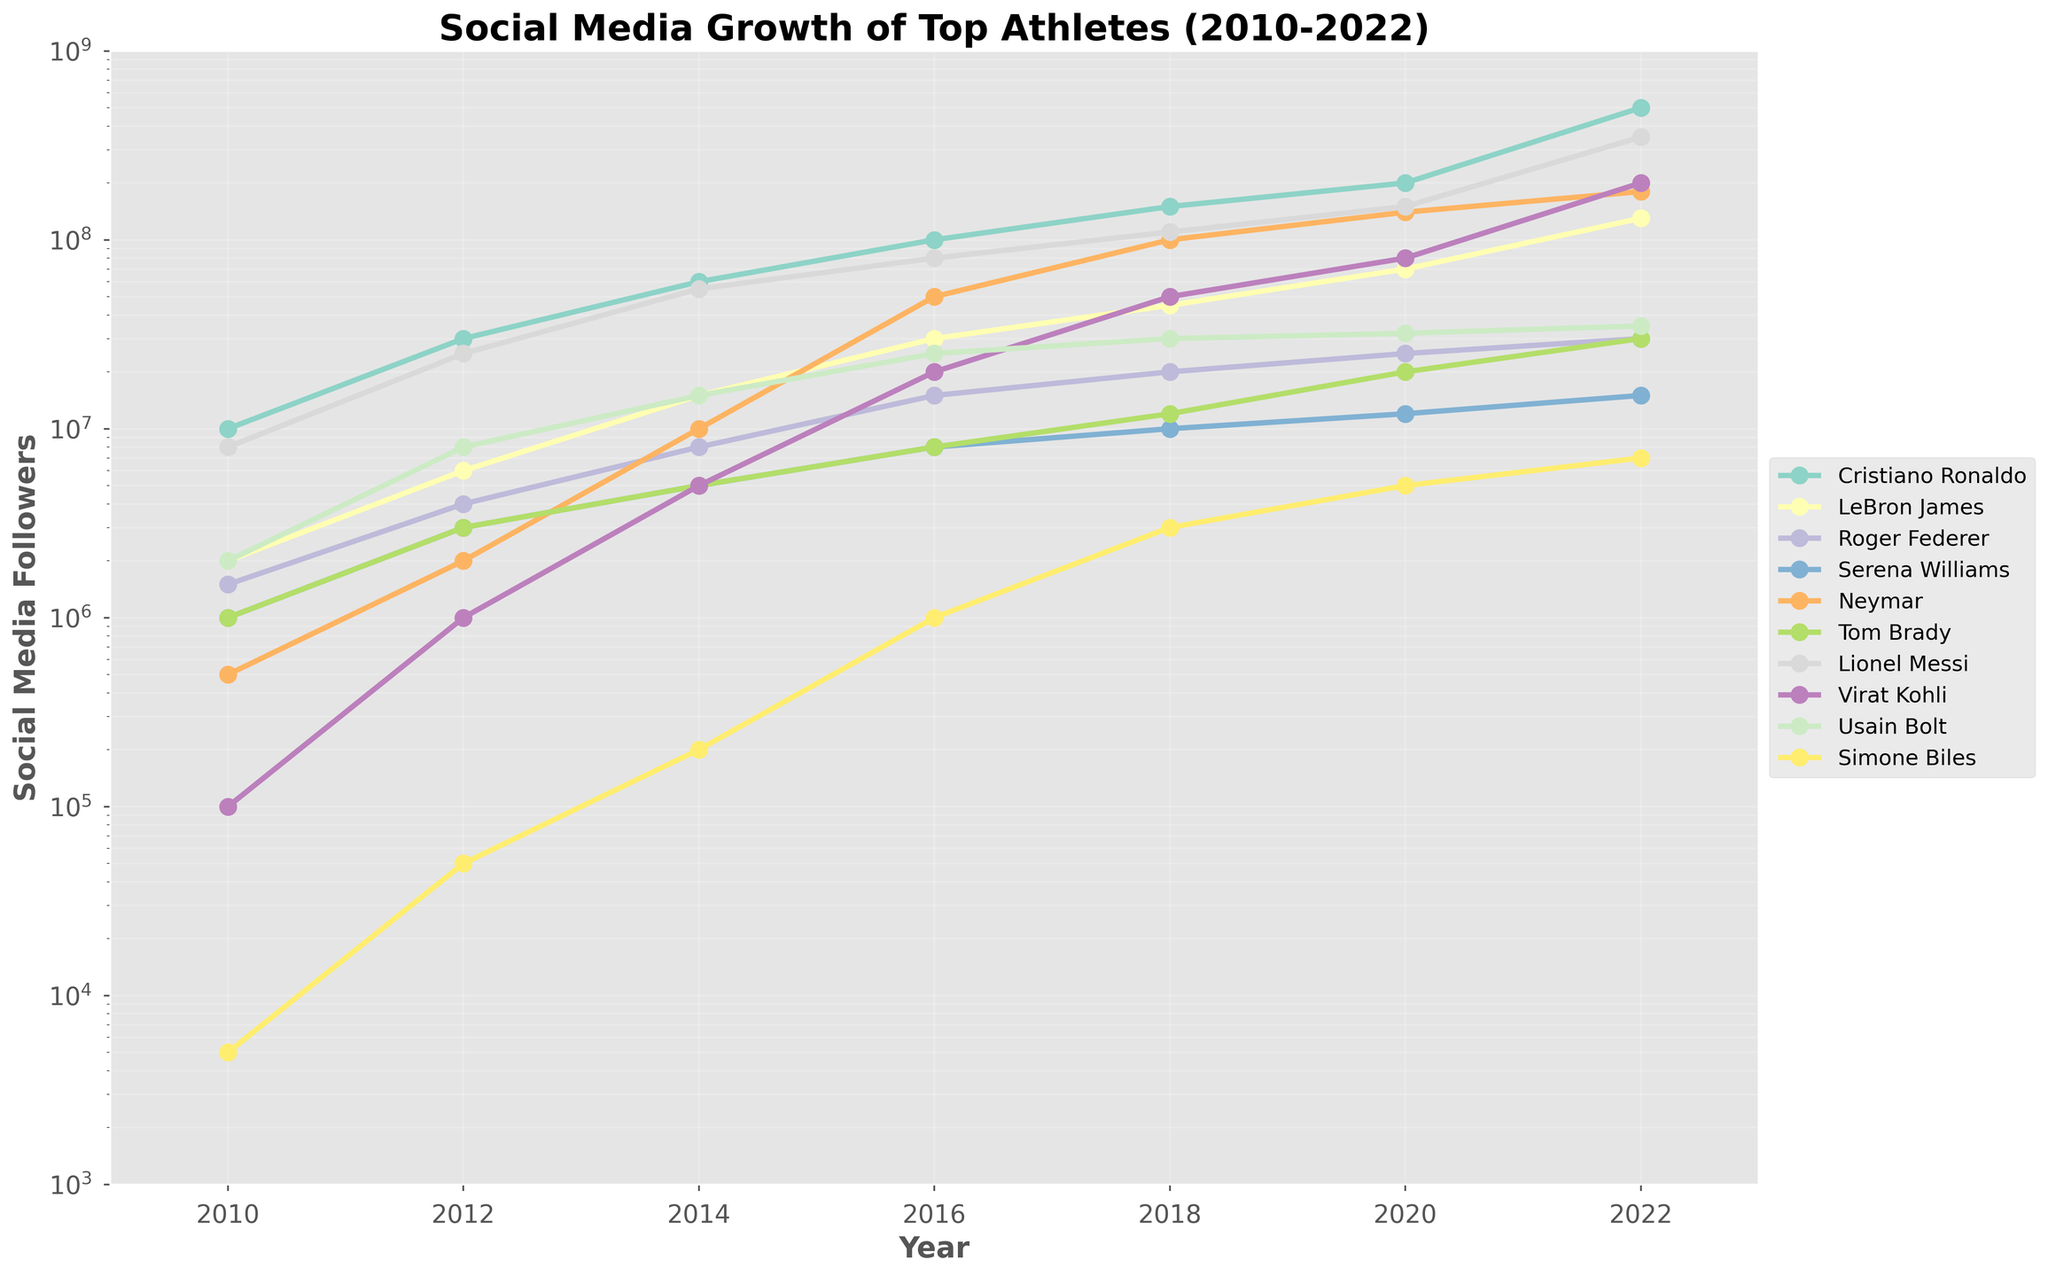Which athlete gained the most followers between 2010 and 2022? To find the answer, examine the starting and ending points of each athlete's follower count line. Cristiano Ronaldo starts at 10 million in 2010 and ends at 500 million in 2022, gaining 490 million followers, which is the highest increase among the athletes.
Answer: Cristiano Ronaldo How did LeBron James' follower growth compare to Neymar's from 2016 to 2020? In 2016, LeBron James had 30 million followers and in 2020, he had 70 million. Neymar had 50 million followers in 2016 and 140 million in 2020. LeBron James gained 40 million followers, while Neymar gained 90 million followers over this period.
Answer: Neymar's growth was faster Who had more followers in 2014, Serena Williams or Tom Brady? In 2014, Serena Williams had 5 million followers and Tom Brady had 5 million followers as well. Hence, both had the same number of followers that year.
Answer: Equal Whose follower count grew faster between Virat Kohli and Usain Bolt from 2018 to 2022? Virat Kohli's followers increased from 50 million in 2018 to 200 million in 2022, a gain of 150 million. Usain Bolt's followers increased from 30 million to 35 million in the same period, a gain of 5 million. Therefore, Virat Kohli's follower count grew faster.
Answer: Virat Kohli Which athlete had the smallest follower count in 2022 and what was it? Review the ending points of the lines in 2022. Simone Biles ended with the smallest follower count at 7 million followers.
Answer: Simone Biles, 7 million Between which years did Lionel Messi experience his largest single increase in followers? To find the largest single increase, review the slopes of Lionel Messi's line segment between each pair of years. The largest increase was between 2020 (150 million) and 2022 (350 million), a gain of 200 million.
Answer: 2020 to 2022 In what year did Cristiano Ronaldo surpass 100 million followers? Identify the year when Cristiano Ronaldo's follower count first crosses the 100 million mark on the plot. This happened in 2016.
Answer: 2016 What was the combined follower count of Roger Federer and Serena Williams in 2018? Roger Federer had 20 million followers and Serena Williams had 10 million followers in 2018. The combined total is 20 million + 10 million = 30 million.
Answer: 30 million Who had more followers in 2016, Virat Kohli or Tom Brady? In 2016, Virat Kohli had 20 million followers, while Tom Brady had 8 million followers. Therefore, Virat Kohli had more.
Answer: Virat Kohli Which athlete had a significant increase in followers after 2018? By observing the slope changes most notably after 2018, Virat Kohli had a significant increase, rising from 50 million in 2018 to 200 million in 2022, making a 150 million increase.
Answer: Virat Kohli 